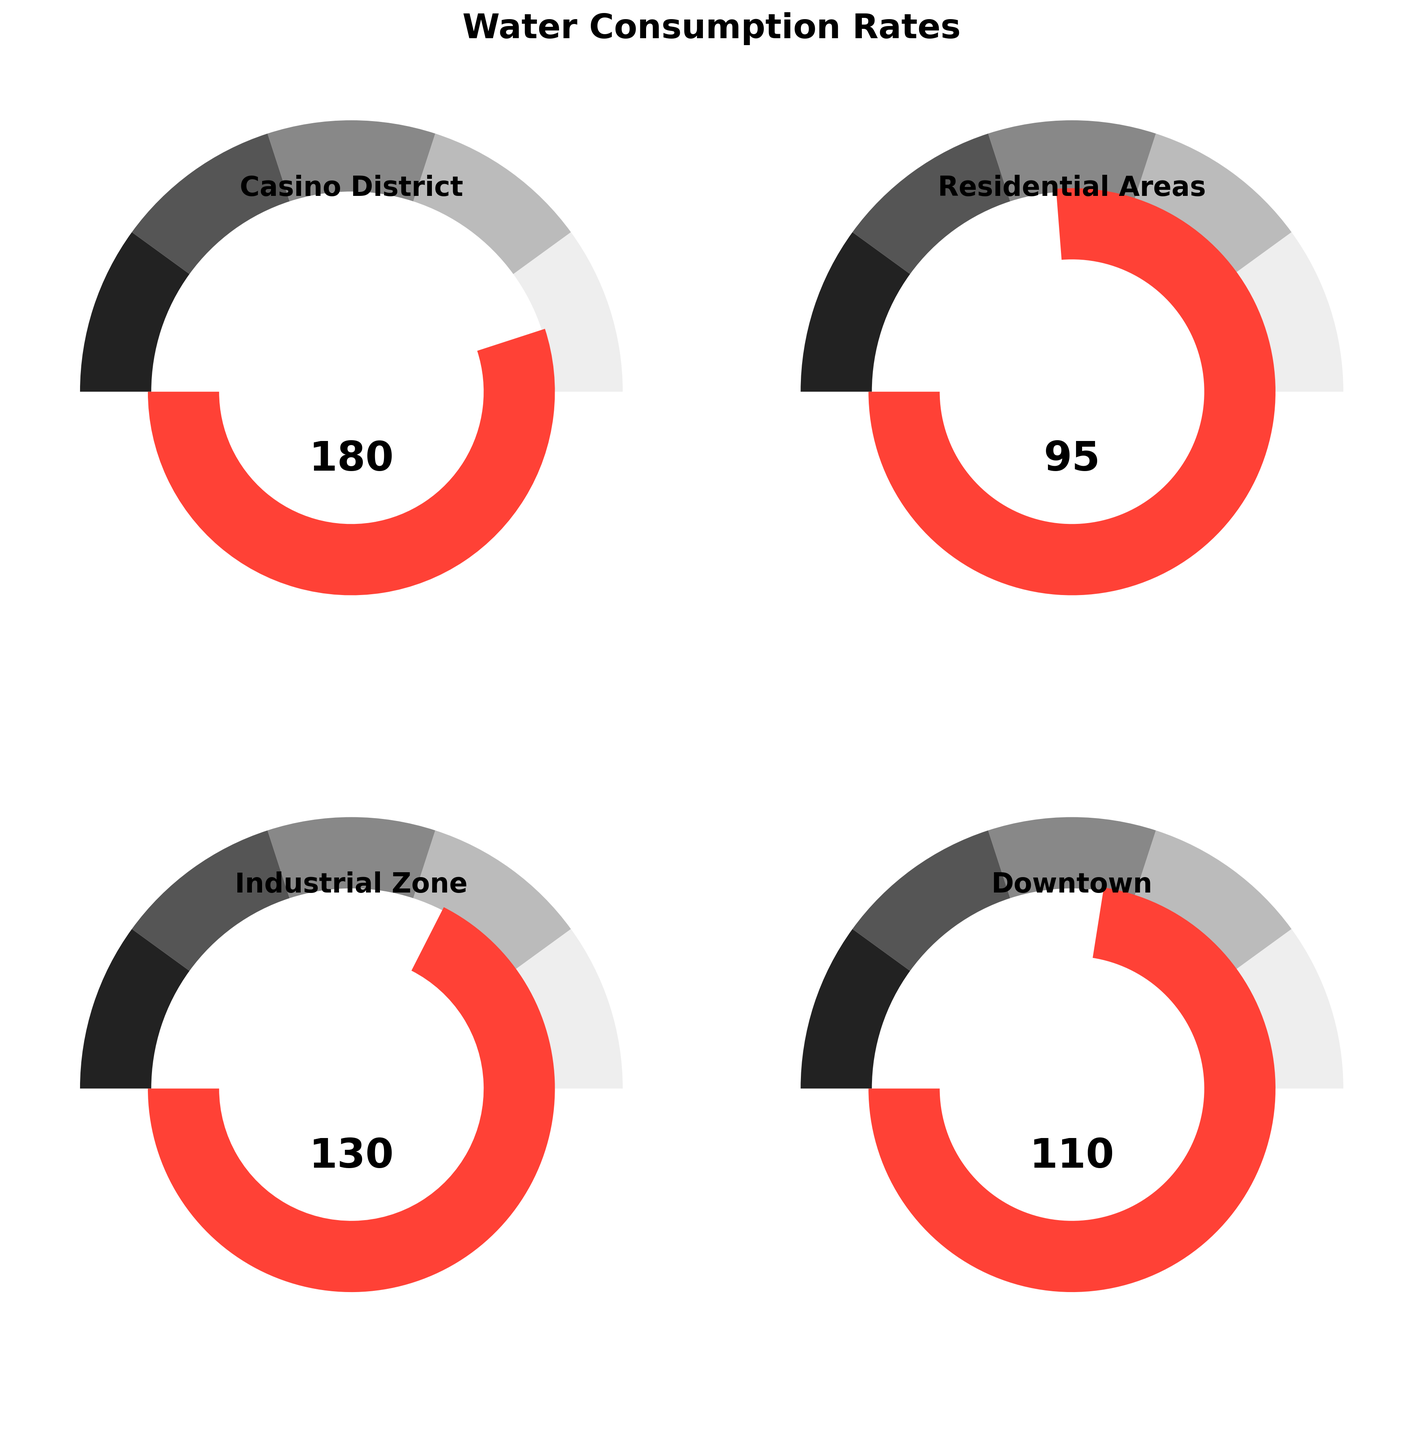What is the title of the figure? The title of the figure is mentioned at the top of the plot. It shows the overall subject of the plot.
Answer: Water Consumption Rates What does the needle in the gauge represent for the Casino District? The needle in the gauge indicates the water consumption rate for each district, in gallons per capita per day. For the Casino District, it points to a specific value on the gauge.
Answer: 180 How does the water consumption in the Casino District compare to the city average? By looking at the needle position and the numeric value presented, we see that the Casino District's water consumption is higher than the city average.
Answer: It is higher Which area has the lowest water consumption compared to others shown in the figure? To answer this, we need to compare the values shown for each area. Residential Areas show the lowest number.
Answer: Residential Areas What is the difference in water consumption between the Casino District and the Industrial Zone? First, identify the water consumption rates for both the Casino District and the Industrial Zone. Then subtract the Industrial Zone's value from the Casino District's value.
Answer: 50 gallons per capita per day (180 - 130) Rank the districts based on their water consumption rates from highest to lowest. To rank the districts, list their water consumption rates and order them from highest to lowest. The values are: Casino District (180), Industrial Zone (130), Downtown (110), Residential Areas (95).
Answer: Casino District > Industrial Zone > Downtown > Residential Areas Which district consumes almost double the water compared to the Residential Areas? To answer this, find the water consumption rate for the Residential Areas and see which district's consumption is close to double that value. The Residential Areas have a rate of 95, and the Casino District is closest to double this value.
Answer: Casino District What is the average water consumption rate for the Industrial Zone and Downtown areas? To find the average, add the water consumption rates for the Industrial Zone and Downtown, then divide by the number of districts (2). (130 + 110) / 2 = 120
Answer: 120 Do any districts have water consumption rates that are close to the city-wide average? Look for the values that are nearest to the city-wide average of 100 gallons per capita per day. Downtown and Residential Areas could be considered close.
Answer: Downtown and Residential Areas 